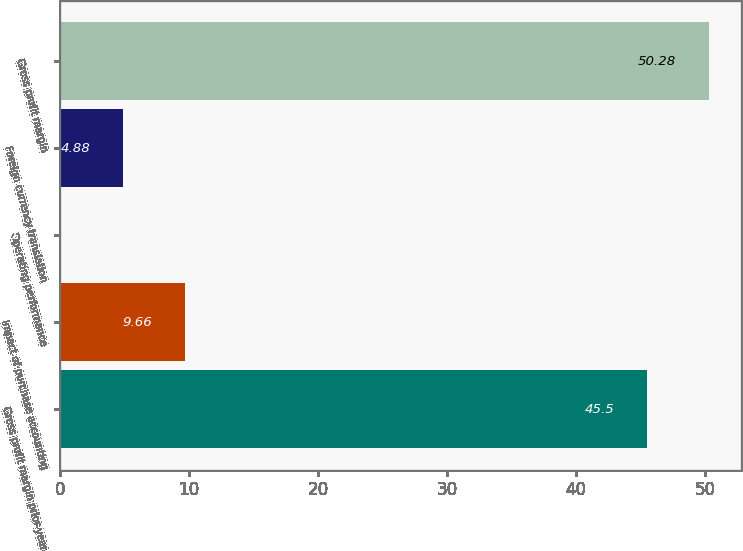Convert chart. <chart><loc_0><loc_0><loc_500><loc_500><bar_chart><fcel>Gross profit margin prior-year<fcel>Impact of purchase accounting<fcel>Operating performance<fcel>Foreign currency translation<fcel>Gross profit margin<nl><fcel>45.5<fcel>9.66<fcel>0.1<fcel>4.88<fcel>50.28<nl></chart> 